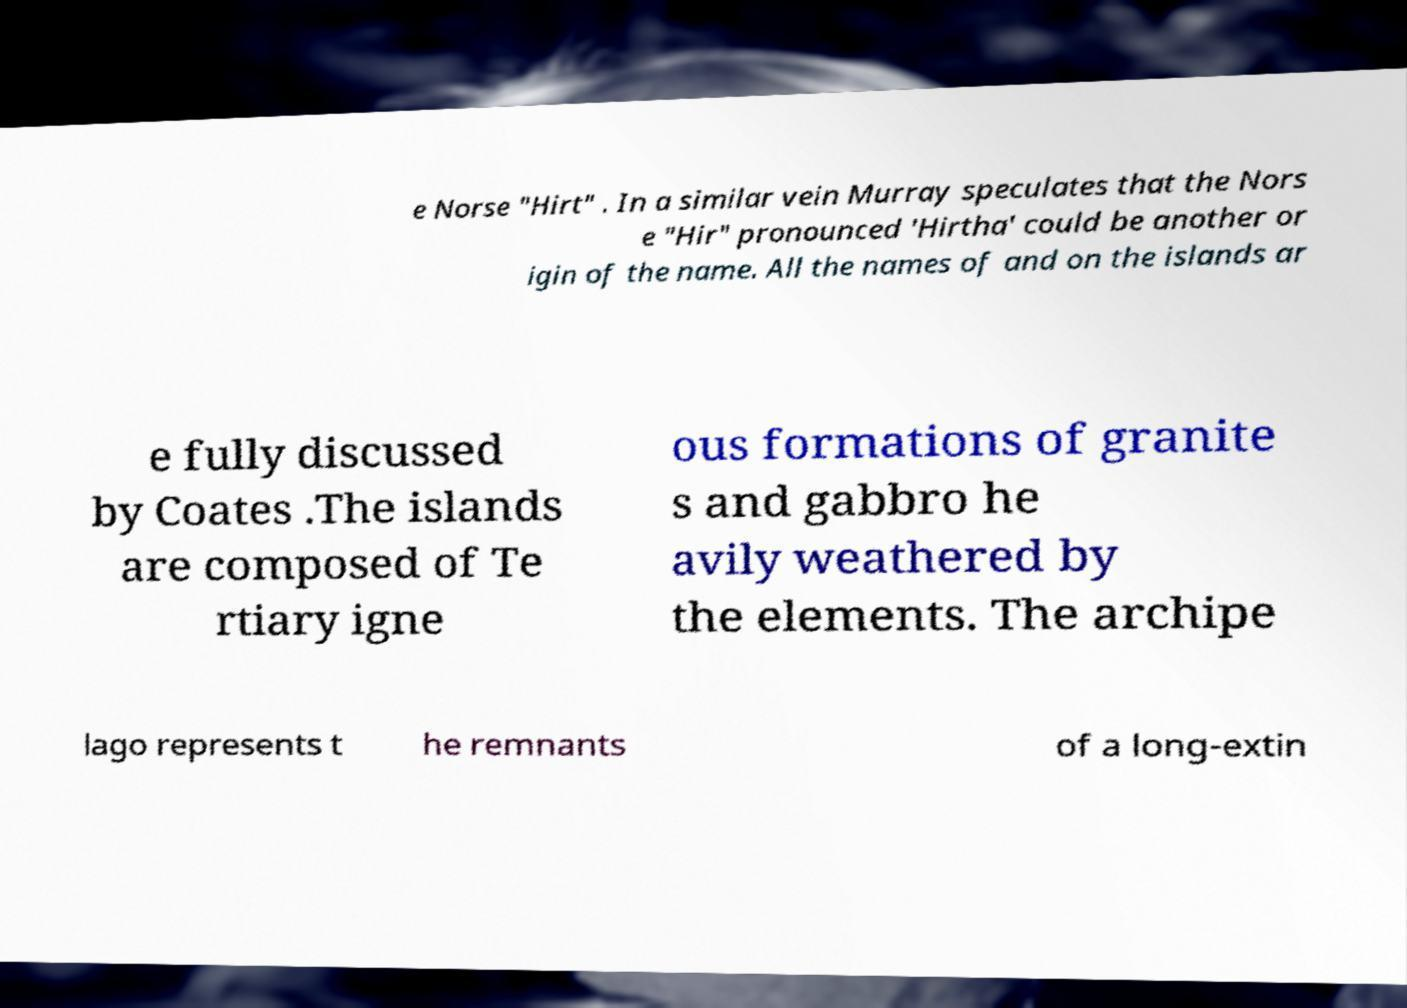There's text embedded in this image that I need extracted. Can you transcribe it verbatim? e Norse "Hirt" . In a similar vein Murray speculates that the Nors e "Hir" pronounced 'Hirtha' could be another or igin of the name. All the names of and on the islands ar e fully discussed by Coates .The islands are composed of Te rtiary igne ous formations of granite s and gabbro he avily weathered by the elements. The archipe lago represents t he remnants of a long-extin 